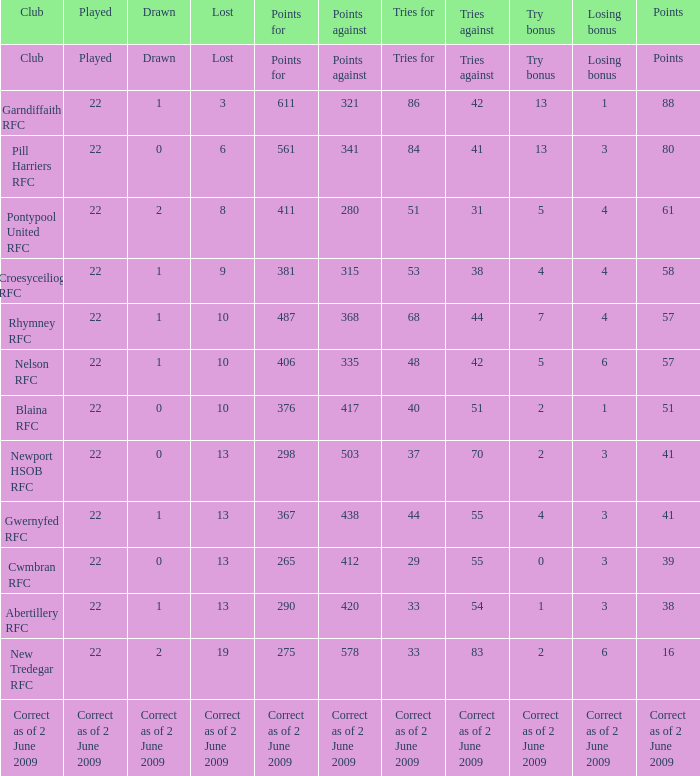How many tries did the club Croesyceiliog rfc have? 53.0. 